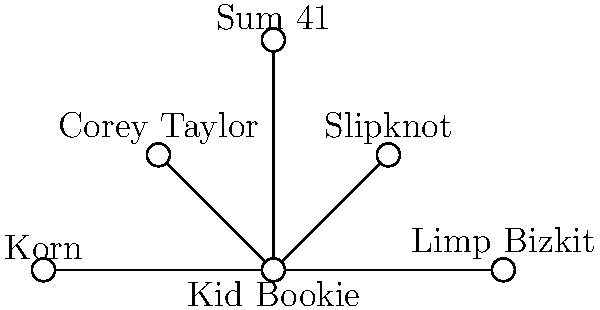In the network diagram illustrating Kid Bookie's musical collaborations and influences, which artist has a direct connection to Kid Bookie and is known for being the lead vocalist of another band also shown in the diagram? To answer this question, we need to analyze the network diagram step-by-step:

1. Kid Bookie is at the center of the diagram, with connections to five other artists/bands.

2. The artists/bands directly connected to Kid Bookie are:
   - Slipknot
   - Corey Taylor
   - Sum 41
   - Korn
   - Limp Bizkit

3. Among these connections, we need to identify an artist who is also the lead vocalist of another band in the diagram.

4. Corey Taylor is directly connected to Kid Bookie.

5. Corey Taylor is well-known as the lead vocalist of Slipknot, which is also shown in the diagram.

6. None of the other artists in the diagram have this dual representation (as an individual artist and as part of a band shown).

Therefore, Corey Taylor is the artist who has a direct connection to Kid Bookie and is known for being the lead vocalist of another band (Slipknot) shown in the diagram.
Answer: Corey Taylor 